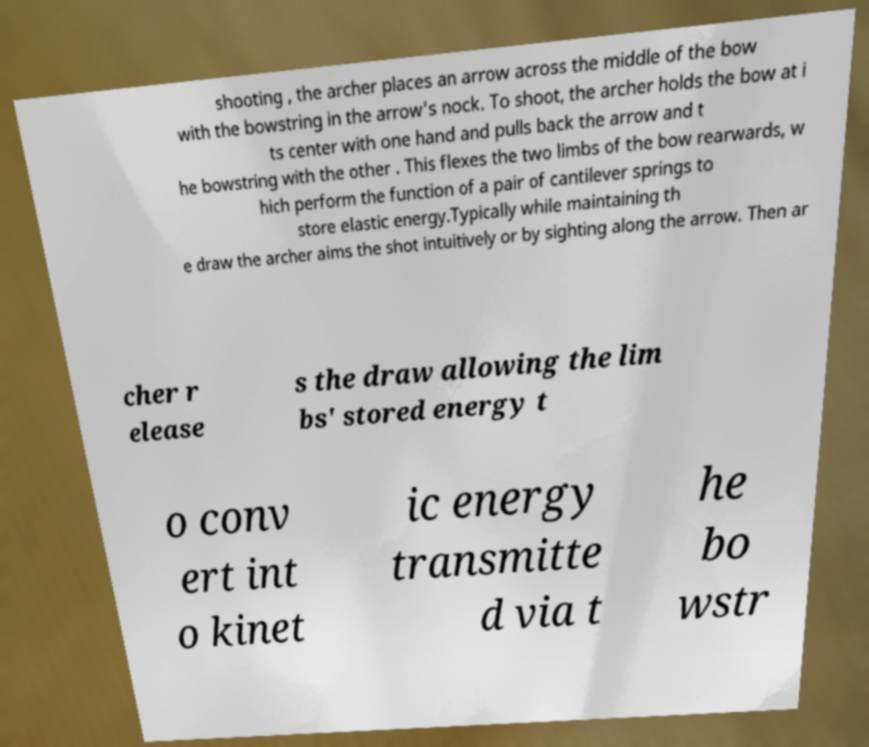Can you read and provide the text displayed in the image?This photo seems to have some interesting text. Can you extract and type it out for me? shooting , the archer places an arrow across the middle of the bow with the bowstring in the arrow's nock. To shoot, the archer holds the bow at i ts center with one hand and pulls back the arrow and t he bowstring with the other . This flexes the two limbs of the bow rearwards, w hich perform the function of a pair of cantilever springs to store elastic energy.Typically while maintaining th e draw the archer aims the shot intuitively or by sighting along the arrow. Then ar cher r elease s the draw allowing the lim bs' stored energy t o conv ert int o kinet ic energy transmitte d via t he bo wstr 